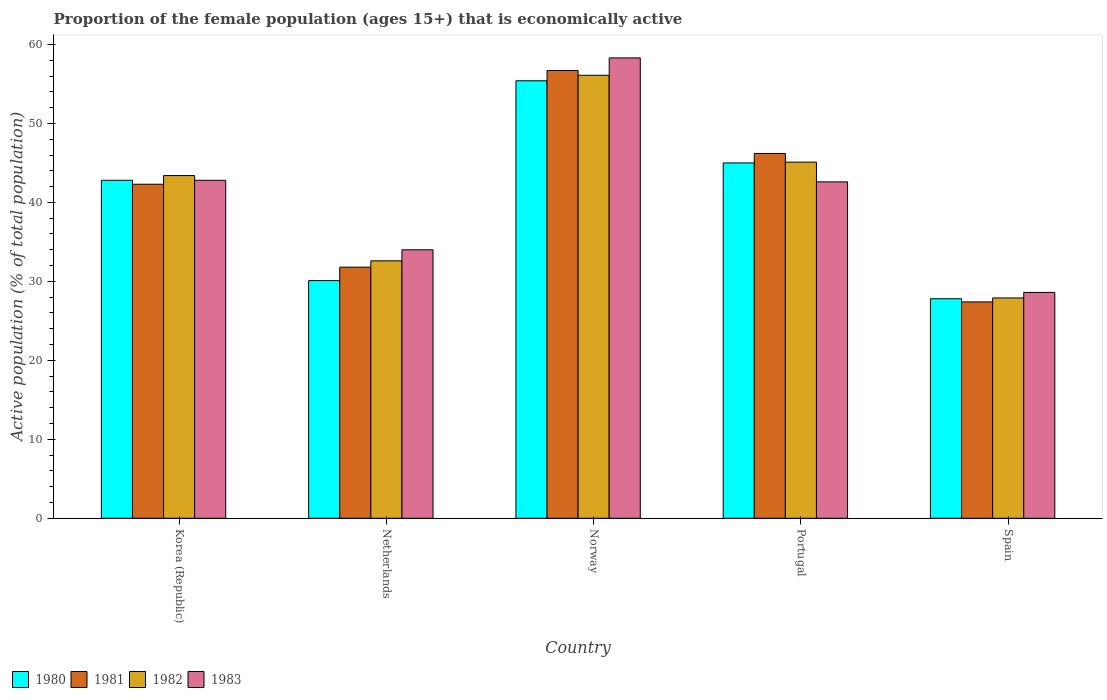Are the number of bars on each tick of the X-axis equal?
Your answer should be compact. Yes. How many bars are there on the 1st tick from the right?
Provide a short and direct response. 4. What is the label of the 3rd group of bars from the left?
Give a very brief answer. Norway. In how many cases, is the number of bars for a given country not equal to the number of legend labels?
Provide a succinct answer. 0. What is the proportion of the female population that is economically active in 1983 in Korea (Republic)?
Offer a terse response. 42.8. Across all countries, what is the maximum proportion of the female population that is economically active in 1980?
Your answer should be very brief. 55.4. Across all countries, what is the minimum proportion of the female population that is economically active in 1980?
Keep it short and to the point. 27.8. In which country was the proportion of the female population that is economically active in 1981 maximum?
Provide a succinct answer. Norway. What is the total proportion of the female population that is economically active in 1981 in the graph?
Offer a very short reply. 204.4. What is the difference between the proportion of the female population that is economically active in 1982 in Netherlands and that in Norway?
Ensure brevity in your answer.  -23.5. What is the difference between the proportion of the female population that is economically active in 1983 in Portugal and the proportion of the female population that is economically active in 1980 in Norway?
Make the answer very short. -12.8. What is the average proportion of the female population that is economically active in 1980 per country?
Keep it short and to the point. 40.22. What is the difference between the proportion of the female population that is economically active of/in 1983 and proportion of the female population that is economically active of/in 1981 in Netherlands?
Ensure brevity in your answer.  2.2. In how many countries, is the proportion of the female population that is economically active in 1981 greater than 50 %?
Ensure brevity in your answer.  1. What is the ratio of the proportion of the female population that is economically active in 1980 in Netherlands to that in Portugal?
Provide a short and direct response. 0.67. Is the difference between the proportion of the female population that is economically active in 1983 in Netherlands and Norway greater than the difference between the proportion of the female population that is economically active in 1981 in Netherlands and Norway?
Your answer should be compact. Yes. What is the difference between the highest and the second highest proportion of the female population that is economically active in 1982?
Your answer should be very brief. 12.7. What is the difference between the highest and the lowest proportion of the female population that is economically active in 1982?
Your answer should be very brief. 28.2. Is the sum of the proportion of the female population that is economically active in 1982 in Norway and Spain greater than the maximum proportion of the female population that is economically active in 1983 across all countries?
Offer a very short reply. Yes. What does the 1st bar from the right in Netherlands represents?
Your answer should be compact. 1983. How many bars are there?
Provide a short and direct response. 20. How many countries are there in the graph?
Offer a terse response. 5. Where does the legend appear in the graph?
Make the answer very short. Bottom left. What is the title of the graph?
Provide a short and direct response. Proportion of the female population (ages 15+) that is economically active. Does "1985" appear as one of the legend labels in the graph?
Ensure brevity in your answer.  No. What is the label or title of the Y-axis?
Provide a succinct answer. Active population (% of total population). What is the Active population (% of total population) in 1980 in Korea (Republic)?
Provide a succinct answer. 42.8. What is the Active population (% of total population) of 1981 in Korea (Republic)?
Your response must be concise. 42.3. What is the Active population (% of total population) of 1982 in Korea (Republic)?
Your response must be concise. 43.4. What is the Active population (% of total population) in 1983 in Korea (Republic)?
Provide a short and direct response. 42.8. What is the Active population (% of total population) in 1980 in Netherlands?
Offer a very short reply. 30.1. What is the Active population (% of total population) of 1981 in Netherlands?
Provide a short and direct response. 31.8. What is the Active population (% of total population) in 1982 in Netherlands?
Make the answer very short. 32.6. What is the Active population (% of total population) of 1983 in Netherlands?
Provide a succinct answer. 34. What is the Active population (% of total population) in 1980 in Norway?
Your response must be concise. 55.4. What is the Active population (% of total population) of 1981 in Norway?
Your response must be concise. 56.7. What is the Active population (% of total population) in 1982 in Norway?
Provide a succinct answer. 56.1. What is the Active population (% of total population) of 1983 in Norway?
Your answer should be very brief. 58.3. What is the Active population (% of total population) in 1981 in Portugal?
Make the answer very short. 46.2. What is the Active population (% of total population) of 1982 in Portugal?
Your answer should be very brief. 45.1. What is the Active population (% of total population) in 1983 in Portugal?
Make the answer very short. 42.6. What is the Active population (% of total population) of 1980 in Spain?
Keep it short and to the point. 27.8. What is the Active population (% of total population) of 1981 in Spain?
Provide a succinct answer. 27.4. What is the Active population (% of total population) in 1982 in Spain?
Provide a succinct answer. 27.9. What is the Active population (% of total population) of 1983 in Spain?
Keep it short and to the point. 28.6. Across all countries, what is the maximum Active population (% of total population) in 1980?
Provide a short and direct response. 55.4. Across all countries, what is the maximum Active population (% of total population) of 1981?
Give a very brief answer. 56.7. Across all countries, what is the maximum Active population (% of total population) of 1982?
Your answer should be compact. 56.1. Across all countries, what is the maximum Active population (% of total population) in 1983?
Keep it short and to the point. 58.3. Across all countries, what is the minimum Active population (% of total population) of 1980?
Provide a short and direct response. 27.8. Across all countries, what is the minimum Active population (% of total population) in 1981?
Ensure brevity in your answer.  27.4. Across all countries, what is the minimum Active population (% of total population) in 1982?
Your answer should be compact. 27.9. Across all countries, what is the minimum Active population (% of total population) in 1983?
Keep it short and to the point. 28.6. What is the total Active population (% of total population) of 1980 in the graph?
Provide a succinct answer. 201.1. What is the total Active population (% of total population) of 1981 in the graph?
Offer a terse response. 204.4. What is the total Active population (% of total population) of 1982 in the graph?
Your answer should be very brief. 205.1. What is the total Active population (% of total population) in 1983 in the graph?
Your answer should be compact. 206.3. What is the difference between the Active population (% of total population) in 1980 in Korea (Republic) and that in Netherlands?
Make the answer very short. 12.7. What is the difference between the Active population (% of total population) of 1981 in Korea (Republic) and that in Netherlands?
Your answer should be very brief. 10.5. What is the difference between the Active population (% of total population) in 1983 in Korea (Republic) and that in Netherlands?
Offer a very short reply. 8.8. What is the difference between the Active population (% of total population) of 1980 in Korea (Republic) and that in Norway?
Your answer should be very brief. -12.6. What is the difference between the Active population (% of total population) of 1981 in Korea (Republic) and that in Norway?
Provide a succinct answer. -14.4. What is the difference between the Active population (% of total population) of 1982 in Korea (Republic) and that in Norway?
Keep it short and to the point. -12.7. What is the difference between the Active population (% of total population) of 1983 in Korea (Republic) and that in Norway?
Give a very brief answer. -15.5. What is the difference between the Active population (% of total population) of 1980 in Korea (Republic) and that in Portugal?
Provide a short and direct response. -2.2. What is the difference between the Active population (% of total population) of 1982 in Korea (Republic) and that in Portugal?
Offer a terse response. -1.7. What is the difference between the Active population (% of total population) in 1981 in Korea (Republic) and that in Spain?
Your answer should be compact. 14.9. What is the difference between the Active population (% of total population) in 1982 in Korea (Republic) and that in Spain?
Keep it short and to the point. 15.5. What is the difference between the Active population (% of total population) in 1983 in Korea (Republic) and that in Spain?
Your answer should be compact. 14.2. What is the difference between the Active population (% of total population) of 1980 in Netherlands and that in Norway?
Your response must be concise. -25.3. What is the difference between the Active population (% of total population) in 1981 in Netherlands and that in Norway?
Keep it short and to the point. -24.9. What is the difference between the Active population (% of total population) of 1982 in Netherlands and that in Norway?
Your answer should be compact. -23.5. What is the difference between the Active population (% of total population) of 1983 in Netherlands and that in Norway?
Keep it short and to the point. -24.3. What is the difference between the Active population (% of total population) in 1980 in Netherlands and that in Portugal?
Offer a terse response. -14.9. What is the difference between the Active population (% of total population) of 1981 in Netherlands and that in Portugal?
Make the answer very short. -14.4. What is the difference between the Active population (% of total population) in 1982 in Netherlands and that in Portugal?
Make the answer very short. -12.5. What is the difference between the Active population (% of total population) in 1983 in Netherlands and that in Portugal?
Your response must be concise. -8.6. What is the difference between the Active population (% of total population) of 1981 in Netherlands and that in Spain?
Provide a succinct answer. 4.4. What is the difference between the Active population (% of total population) of 1983 in Norway and that in Portugal?
Provide a succinct answer. 15.7. What is the difference between the Active population (% of total population) in 1980 in Norway and that in Spain?
Offer a very short reply. 27.6. What is the difference between the Active population (% of total population) of 1981 in Norway and that in Spain?
Your answer should be compact. 29.3. What is the difference between the Active population (% of total population) of 1982 in Norway and that in Spain?
Provide a succinct answer. 28.2. What is the difference between the Active population (% of total population) of 1983 in Norway and that in Spain?
Give a very brief answer. 29.7. What is the difference between the Active population (% of total population) of 1980 in Portugal and that in Spain?
Keep it short and to the point. 17.2. What is the difference between the Active population (% of total population) of 1980 in Korea (Republic) and the Active population (% of total population) of 1981 in Netherlands?
Provide a short and direct response. 11. What is the difference between the Active population (% of total population) in 1980 in Korea (Republic) and the Active population (% of total population) in 1982 in Netherlands?
Your answer should be compact. 10.2. What is the difference between the Active population (% of total population) of 1981 in Korea (Republic) and the Active population (% of total population) of 1982 in Netherlands?
Give a very brief answer. 9.7. What is the difference between the Active population (% of total population) of 1981 in Korea (Republic) and the Active population (% of total population) of 1983 in Netherlands?
Make the answer very short. 8.3. What is the difference between the Active population (% of total population) in 1982 in Korea (Republic) and the Active population (% of total population) in 1983 in Netherlands?
Ensure brevity in your answer.  9.4. What is the difference between the Active population (% of total population) in 1980 in Korea (Republic) and the Active population (% of total population) in 1983 in Norway?
Your answer should be compact. -15.5. What is the difference between the Active population (% of total population) of 1982 in Korea (Republic) and the Active population (% of total population) of 1983 in Norway?
Provide a succinct answer. -14.9. What is the difference between the Active population (% of total population) in 1980 in Korea (Republic) and the Active population (% of total population) in 1983 in Portugal?
Offer a terse response. 0.2. What is the difference between the Active population (% of total population) of 1981 in Korea (Republic) and the Active population (% of total population) of 1982 in Portugal?
Make the answer very short. -2.8. What is the difference between the Active population (% of total population) of 1980 in Korea (Republic) and the Active population (% of total population) of 1981 in Spain?
Your answer should be compact. 15.4. What is the difference between the Active population (% of total population) in 1980 in Korea (Republic) and the Active population (% of total population) in 1982 in Spain?
Provide a succinct answer. 14.9. What is the difference between the Active population (% of total population) in 1980 in Korea (Republic) and the Active population (% of total population) in 1983 in Spain?
Give a very brief answer. 14.2. What is the difference between the Active population (% of total population) of 1982 in Korea (Republic) and the Active population (% of total population) of 1983 in Spain?
Your answer should be very brief. 14.8. What is the difference between the Active population (% of total population) in 1980 in Netherlands and the Active population (% of total population) in 1981 in Norway?
Your response must be concise. -26.6. What is the difference between the Active population (% of total population) in 1980 in Netherlands and the Active population (% of total population) in 1983 in Norway?
Your response must be concise. -28.2. What is the difference between the Active population (% of total population) in 1981 in Netherlands and the Active population (% of total population) in 1982 in Norway?
Your response must be concise. -24.3. What is the difference between the Active population (% of total population) in 1981 in Netherlands and the Active population (% of total population) in 1983 in Norway?
Keep it short and to the point. -26.5. What is the difference between the Active population (% of total population) in 1982 in Netherlands and the Active population (% of total population) in 1983 in Norway?
Give a very brief answer. -25.7. What is the difference between the Active population (% of total population) of 1980 in Netherlands and the Active population (% of total population) of 1981 in Portugal?
Provide a short and direct response. -16.1. What is the difference between the Active population (% of total population) of 1980 in Netherlands and the Active population (% of total population) of 1982 in Portugal?
Provide a short and direct response. -15. What is the difference between the Active population (% of total population) in 1981 in Netherlands and the Active population (% of total population) in 1982 in Portugal?
Keep it short and to the point. -13.3. What is the difference between the Active population (% of total population) of 1981 in Netherlands and the Active population (% of total population) of 1983 in Portugal?
Your answer should be very brief. -10.8. What is the difference between the Active population (% of total population) of 1980 in Netherlands and the Active population (% of total population) of 1981 in Spain?
Keep it short and to the point. 2.7. What is the difference between the Active population (% of total population) in 1980 in Netherlands and the Active population (% of total population) in 1982 in Spain?
Your answer should be compact. 2.2. What is the difference between the Active population (% of total population) in 1982 in Netherlands and the Active population (% of total population) in 1983 in Spain?
Your answer should be compact. 4. What is the difference between the Active population (% of total population) of 1980 in Norway and the Active population (% of total population) of 1981 in Portugal?
Offer a very short reply. 9.2. What is the difference between the Active population (% of total population) of 1981 in Norway and the Active population (% of total population) of 1983 in Portugal?
Provide a short and direct response. 14.1. What is the difference between the Active population (% of total population) of 1980 in Norway and the Active population (% of total population) of 1981 in Spain?
Ensure brevity in your answer.  28. What is the difference between the Active population (% of total population) of 1980 in Norway and the Active population (% of total population) of 1982 in Spain?
Offer a terse response. 27.5. What is the difference between the Active population (% of total population) in 1980 in Norway and the Active population (% of total population) in 1983 in Spain?
Make the answer very short. 26.8. What is the difference between the Active population (% of total population) in 1981 in Norway and the Active population (% of total population) in 1982 in Spain?
Ensure brevity in your answer.  28.8. What is the difference between the Active population (% of total population) of 1981 in Norway and the Active population (% of total population) of 1983 in Spain?
Provide a short and direct response. 28.1. What is the difference between the Active population (% of total population) of 1981 in Portugal and the Active population (% of total population) of 1982 in Spain?
Provide a succinct answer. 18.3. What is the difference between the Active population (% of total population) of 1982 in Portugal and the Active population (% of total population) of 1983 in Spain?
Offer a terse response. 16.5. What is the average Active population (% of total population) of 1980 per country?
Your response must be concise. 40.22. What is the average Active population (% of total population) in 1981 per country?
Keep it short and to the point. 40.88. What is the average Active population (% of total population) in 1982 per country?
Give a very brief answer. 41.02. What is the average Active population (% of total population) in 1983 per country?
Provide a succinct answer. 41.26. What is the difference between the Active population (% of total population) in 1980 and Active population (% of total population) in 1982 in Korea (Republic)?
Keep it short and to the point. -0.6. What is the difference between the Active population (% of total population) of 1981 and Active population (% of total population) of 1983 in Korea (Republic)?
Make the answer very short. -0.5. What is the difference between the Active population (% of total population) of 1982 and Active population (% of total population) of 1983 in Korea (Republic)?
Offer a terse response. 0.6. What is the difference between the Active population (% of total population) in 1980 and Active population (% of total population) in 1981 in Netherlands?
Provide a succinct answer. -1.7. What is the difference between the Active population (% of total population) in 1981 and Active population (% of total population) in 1982 in Netherlands?
Give a very brief answer. -0.8. What is the difference between the Active population (% of total population) of 1982 and Active population (% of total population) of 1983 in Netherlands?
Your response must be concise. -1.4. What is the difference between the Active population (% of total population) in 1980 and Active population (% of total population) in 1982 in Norway?
Your answer should be compact. -0.7. What is the difference between the Active population (% of total population) in 1982 and Active population (% of total population) in 1983 in Norway?
Provide a succinct answer. -2.2. What is the difference between the Active population (% of total population) of 1980 and Active population (% of total population) of 1981 in Portugal?
Provide a short and direct response. -1.2. What is the difference between the Active population (% of total population) of 1980 and Active population (% of total population) of 1982 in Portugal?
Provide a short and direct response. -0.1. What is the difference between the Active population (% of total population) of 1982 and Active population (% of total population) of 1983 in Portugal?
Your response must be concise. 2.5. What is the difference between the Active population (% of total population) in 1980 and Active population (% of total population) in 1983 in Spain?
Keep it short and to the point. -0.8. What is the difference between the Active population (% of total population) of 1981 and Active population (% of total population) of 1982 in Spain?
Provide a short and direct response. -0.5. What is the difference between the Active population (% of total population) of 1981 and Active population (% of total population) of 1983 in Spain?
Keep it short and to the point. -1.2. What is the difference between the Active population (% of total population) in 1982 and Active population (% of total population) in 1983 in Spain?
Your answer should be very brief. -0.7. What is the ratio of the Active population (% of total population) of 1980 in Korea (Republic) to that in Netherlands?
Offer a very short reply. 1.42. What is the ratio of the Active population (% of total population) of 1981 in Korea (Republic) to that in Netherlands?
Your answer should be very brief. 1.33. What is the ratio of the Active population (% of total population) of 1982 in Korea (Republic) to that in Netherlands?
Your answer should be compact. 1.33. What is the ratio of the Active population (% of total population) in 1983 in Korea (Republic) to that in Netherlands?
Give a very brief answer. 1.26. What is the ratio of the Active population (% of total population) in 1980 in Korea (Republic) to that in Norway?
Your response must be concise. 0.77. What is the ratio of the Active population (% of total population) of 1981 in Korea (Republic) to that in Norway?
Offer a terse response. 0.75. What is the ratio of the Active population (% of total population) of 1982 in Korea (Republic) to that in Norway?
Offer a very short reply. 0.77. What is the ratio of the Active population (% of total population) in 1983 in Korea (Republic) to that in Norway?
Your response must be concise. 0.73. What is the ratio of the Active population (% of total population) of 1980 in Korea (Republic) to that in Portugal?
Your answer should be very brief. 0.95. What is the ratio of the Active population (% of total population) of 1981 in Korea (Republic) to that in Portugal?
Keep it short and to the point. 0.92. What is the ratio of the Active population (% of total population) of 1982 in Korea (Republic) to that in Portugal?
Your response must be concise. 0.96. What is the ratio of the Active population (% of total population) of 1983 in Korea (Republic) to that in Portugal?
Keep it short and to the point. 1. What is the ratio of the Active population (% of total population) in 1980 in Korea (Republic) to that in Spain?
Offer a terse response. 1.54. What is the ratio of the Active population (% of total population) of 1981 in Korea (Republic) to that in Spain?
Give a very brief answer. 1.54. What is the ratio of the Active population (% of total population) in 1982 in Korea (Republic) to that in Spain?
Give a very brief answer. 1.56. What is the ratio of the Active population (% of total population) of 1983 in Korea (Republic) to that in Spain?
Offer a very short reply. 1.5. What is the ratio of the Active population (% of total population) in 1980 in Netherlands to that in Norway?
Your answer should be very brief. 0.54. What is the ratio of the Active population (% of total population) of 1981 in Netherlands to that in Norway?
Make the answer very short. 0.56. What is the ratio of the Active population (% of total population) of 1982 in Netherlands to that in Norway?
Your response must be concise. 0.58. What is the ratio of the Active population (% of total population) of 1983 in Netherlands to that in Norway?
Provide a succinct answer. 0.58. What is the ratio of the Active population (% of total population) in 1980 in Netherlands to that in Portugal?
Offer a terse response. 0.67. What is the ratio of the Active population (% of total population) of 1981 in Netherlands to that in Portugal?
Your answer should be very brief. 0.69. What is the ratio of the Active population (% of total population) in 1982 in Netherlands to that in Portugal?
Keep it short and to the point. 0.72. What is the ratio of the Active population (% of total population) in 1983 in Netherlands to that in Portugal?
Your answer should be compact. 0.8. What is the ratio of the Active population (% of total population) in 1980 in Netherlands to that in Spain?
Offer a terse response. 1.08. What is the ratio of the Active population (% of total population) in 1981 in Netherlands to that in Spain?
Offer a very short reply. 1.16. What is the ratio of the Active population (% of total population) of 1982 in Netherlands to that in Spain?
Offer a very short reply. 1.17. What is the ratio of the Active population (% of total population) in 1983 in Netherlands to that in Spain?
Give a very brief answer. 1.19. What is the ratio of the Active population (% of total population) of 1980 in Norway to that in Portugal?
Your response must be concise. 1.23. What is the ratio of the Active population (% of total population) of 1981 in Norway to that in Portugal?
Provide a short and direct response. 1.23. What is the ratio of the Active population (% of total population) in 1982 in Norway to that in Portugal?
Provide a succinct answer. 1.24. What is the ratio of the Active population (% of total population) in 1983 in Norway to that in Portugal?
Offer a very short reply. 1.37. What is the ratio of the Active population (% of total population) of 1980 in Norway to that in Spain?
Give a very brief answer. 1.99. What is the ratio of the Active population (% of total population) in 1981 in Norway to that in Spain?
Keep it short and to the point. 2.07. What is the ratio of the Active population (% of total population) of 1982 in Norway to that in Spain?
Keep it short and to the point. 2.01. What is the ratio of the Active population (% of total population) in 1983 in Norway to that in Spain?
Offer a very short reply. 2.04. What is the ratio of the Active population (% of total population) in 1980 in Portugal to that in Spain?
Make the answer very short. 1.62. What is the ratio of the Active population (% of total population) in 1981 in Portugal to that in Spain?
Provide a succinct answer. 1.69. What is the ratio of the Active population (% of total population) of 1982 in Portugal to that in Spain?
Provide a short and direct response. 1.62. What is the ratio of the Active population (% of total population) in 1983 in Portugal to that in Spain?
Your answer should be compact. 1.49. What is the difference between the highest and the second highest Active population (% of total population) in 1980?
Provide a succinct answer. 10.4. What is the difference between the highest and the second highest Active population (% of total population) of 1981?
Make the answer very short. 10.5. What is the difference between the highest and the second highest Active population (% of total population) of 1982?
Provide a succinct answer. 11. What is the difference between the highest and the lowest Active population (% of total population) of 1980?
Offer a very short reply. 27.6. What is the difference between the highest and the lowest Active population (% of total population) in 1981?
Provide a short and direct response. 29.3. What is the difference between the highest and the lowest Active population (% of total population) in 1982?
Offer a terse response. 28.2. What is the difference between the highest and the lowest Active population (% of total population) in 1983?
Keep it short and to the point. 29.7. 